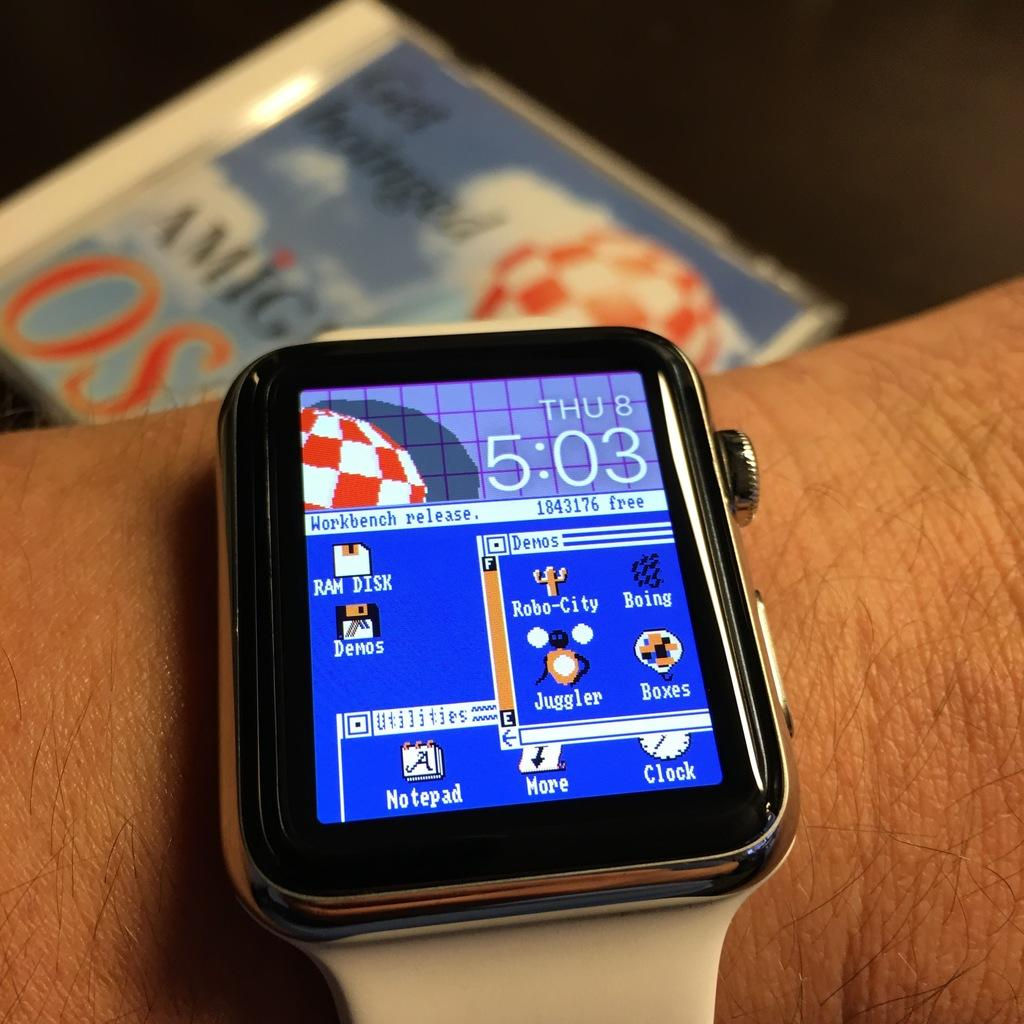<image>
Share a concise interpretation of the image provided. A smart watch displays a workbench with Raw disk and demos no it 